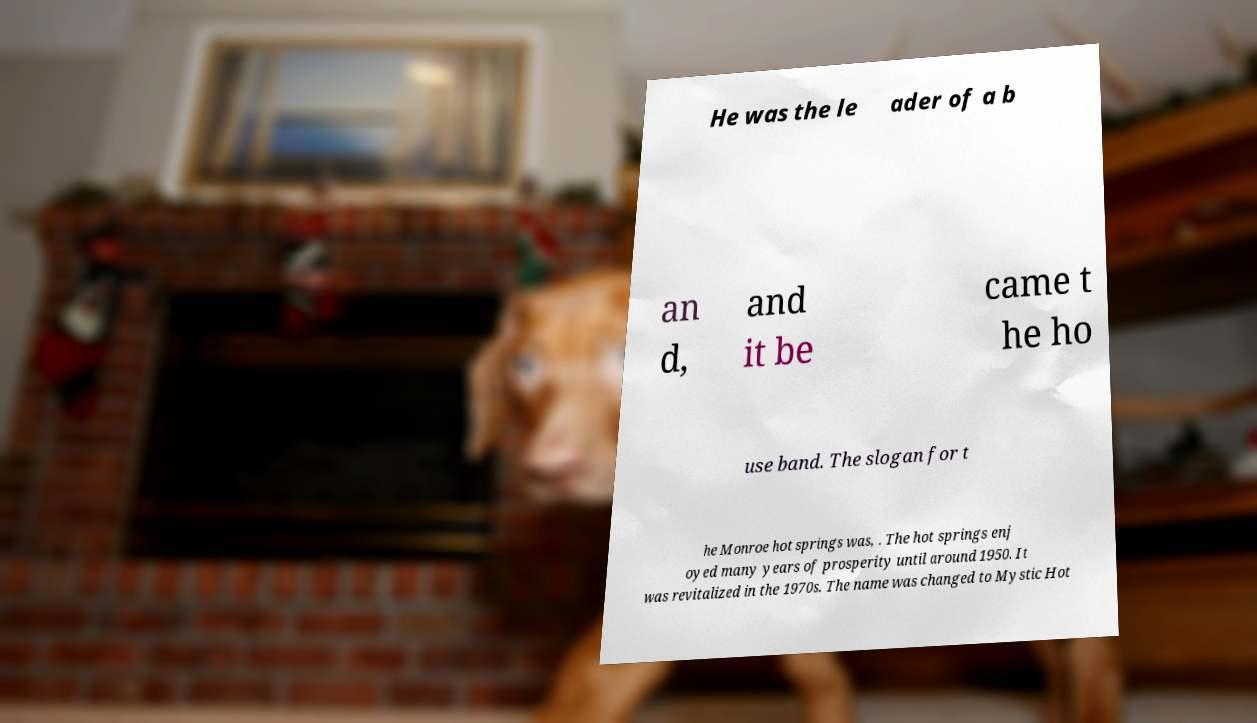There's text embedded in this image that I need extracted. Can you transcribe it verbatim? He was the le ader of a b an d, and it be came t he ho use band. The slogan for t he Monroe hot springs was, . The hot springs enj oyed many years of prosperity until around 1950. It was revitalized in the 1970s. The name was changed to Mystic Hot 